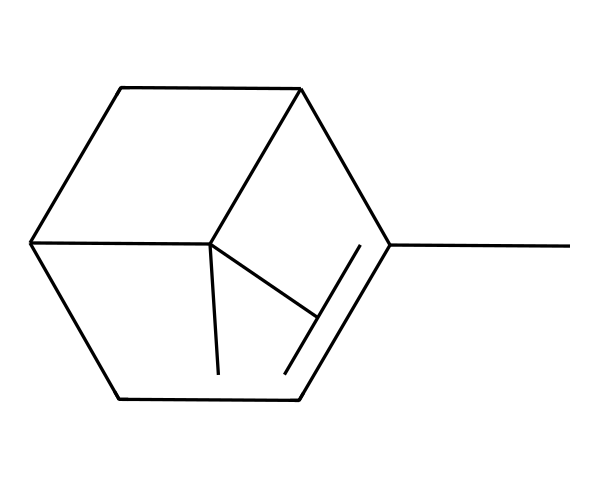What is the name of this compound? The SMILES representation corresponds to a structure known as pinene, which is a well-known terpene. Recognizing the specific structural features and the common use in cleaning products leads to this identification.
Answer: pinene How many carbon atoms are present in this compound? The SMILES notation indicates that there are multiple carbon atoms arranged in a cyclical and branched structure. Counting the "C" symbols in the SMILES shows there are 10 carbon atoms.
Answer: 10 What type of aromatic feature does this terpene possess? This molecule is a cyclic structure, indicating it has a ring system. However, since it is specified as a terpene, it is classified as a bicyclic structure, where two rings are fused.
Answer: bicyclic What functional groups are present in this structure? Analyzing the chemical structure from the SMILES indicates it does not have any functional groups like -OH or =O. It primarily displays hydrocarbon characteristics typical of terpenes.
Answer: none Is this compound polar or non-polar? Given that pinene is composed mainly of carbon and hydrogen without any highly electronegative atoms present, it can be inferred to be non-polar due to its hydrocarbon nature.
Answer: non-polar What is the general category of this chemical structure? This compound belongs to the class of natural compounds known as terpenes, which are derived from plant sources and have various applications, including fragrance and flavor.
Answer: terpene 